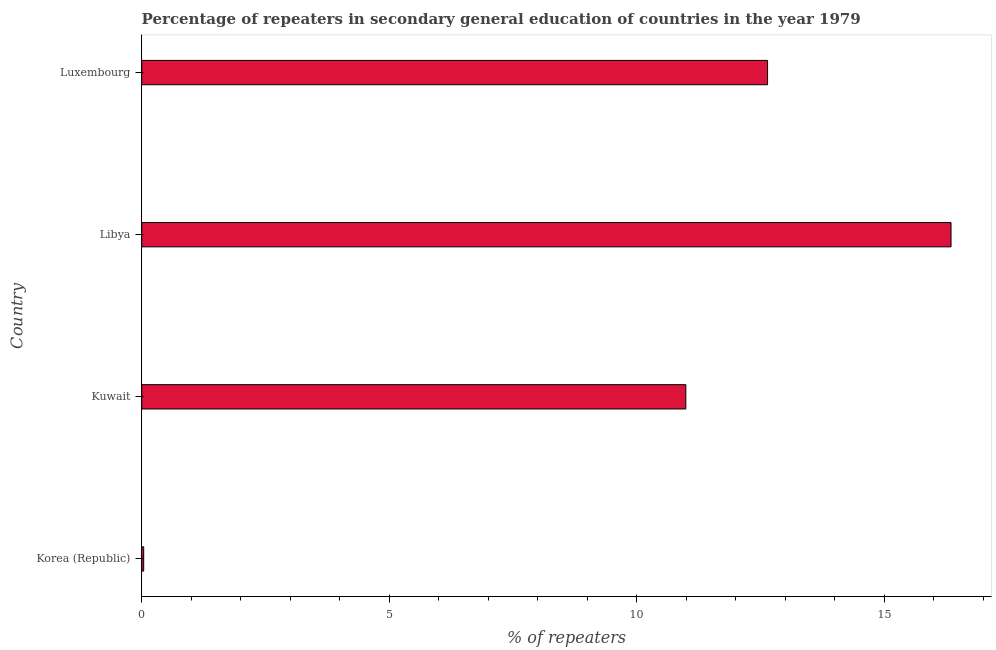Does the graph contain any zero values?
Provide a short and direct response. No. What is the title of the graph?
Provide a short and direct response. Percentage of repeaters in secondary general education of countries in the year 1979. What is the label or title of the X-axis?
Keep it short and to the point. % of repeaters. What is the label or title of the Y-axis?
Offer a terse response. Country. What is the percentage of repeaters in Libya?
Your answer should be compact. 16.35. Across all countries, what is the maximum percentage of repeaters?
Keep it short and to the point. 16.35. Across all countries, what is the minimum percentage of repeaters?
Keep it short and to the point. 0.04. In which country was the percentage of repeaters maximum?
Your answer should be very brief. Libya. In which country was the percentage of repeaters minimum?
Ensure brevity in your answer.  Korea (Republic). What is the sum of the percentage of repeaters?
Make the answer very short. 40.02. What is the difference between the percentage of repeaters in Korea (Republic) and Luxembourg?
Your answer should be compact. -12.6. What is the average percentage of repeaters per country?
Give a very brief answer. 10. What is the median percentage of repeaters?
Give a very brief answer. 11.82. What is the ratio of the percentage of repeaters in Korea (Republic) to that in Libya?
Make the answer very short. 0. Is the percentage of repeaters in Korea (Republic) less than that in Libya?
Your answer should be very brief. Yes. Is the difference between the percentage of repeaters in Korea (Republic) and Luxembourg greater than the difference between any two countries?
Provide a succinct answer. No. What is the difference between the highest and the second highest percentage of repeaters?
Give a very brief answer. 3.71. What is the difference between the highest and the lowest percentage of repeaters?
Keep it short and to the point. 16.31. How many bars are there?
Give a very brief answer. 4. Are all the bars in the graph horizontal?
Your answer should be very brief. Yes. How many countries are there in the graph?
Make the answer very short. 4. What is the difference between two consecutive major ticks on the X-axis?
Ensure brevity in your answer.  5. Are the values on the major ticks of X-axis written in scientific E-notation?
Make the answer very short. No. What is the % of repeaters in Korea (Republic)?
Give a very brief answer. 0.04. What is the % of repeaters of Kuwait?
Provide a succinct answer. 10.99. What is the % of repeaters in Libya?
Make the answer very short. 16.35. What is the % of repeaters of Luxembourg?
Offer a terse response. 12.64. What is the difference between the % of repeaters in Korea (Republic) and Kuwait?
Your answer should be very brief. -10.95. What is the difference between the % of repeaters in Korea (Republic) and Libya?
Give a very brief answer. -16.31. What is the difference between the % of repeaters in Korea (Republic) and Luxembourg?
Keep it short and to the point. -12.6. What is the difference between the % of repeaters in Kuwait and Libya?
Make the answer very short. -5.36. What is the difference between the % of repeaters in Kuwait and Luxembourg?
Ensure brevity in your answer.  -1.65. What is the difference between the % of repeaters in Libya and Luxembourg?
Your response must be concise. 3.71. What is the ratio of the % of repeaters in Korea (Republic) to that in Kuwait?
Provide a short and direct response. 0. What is the ratio of the % of repeaters in Korea (Republic) to that in Libya?
Give a very brief answer. 0. What is the ratio of the % of repeaters in Korea (Republic) to that in Luxembourg?
Keep it short and to the point. 0. What is the ratio of the % of repeaters in Kuwait to that in Libya?
Make the answer very short. 0.67. What is the ratio of the % of repeaters in Kuwait to that in Luxembourg?
Give a very brief answer. 0.87. What is the ratio of the % of repeaters in Libya to that in Luxembourg?
Provide a short and direct response. 1.29. 